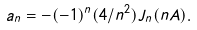Convert formula to latex. <formula><loc_0><loc_0><loc_500><loc_500>a _ { n } = - ( - 1 ) ^ { n } ( 4 / n ^ { 2 } ) J _ { n } ( n A ) .</formula> 